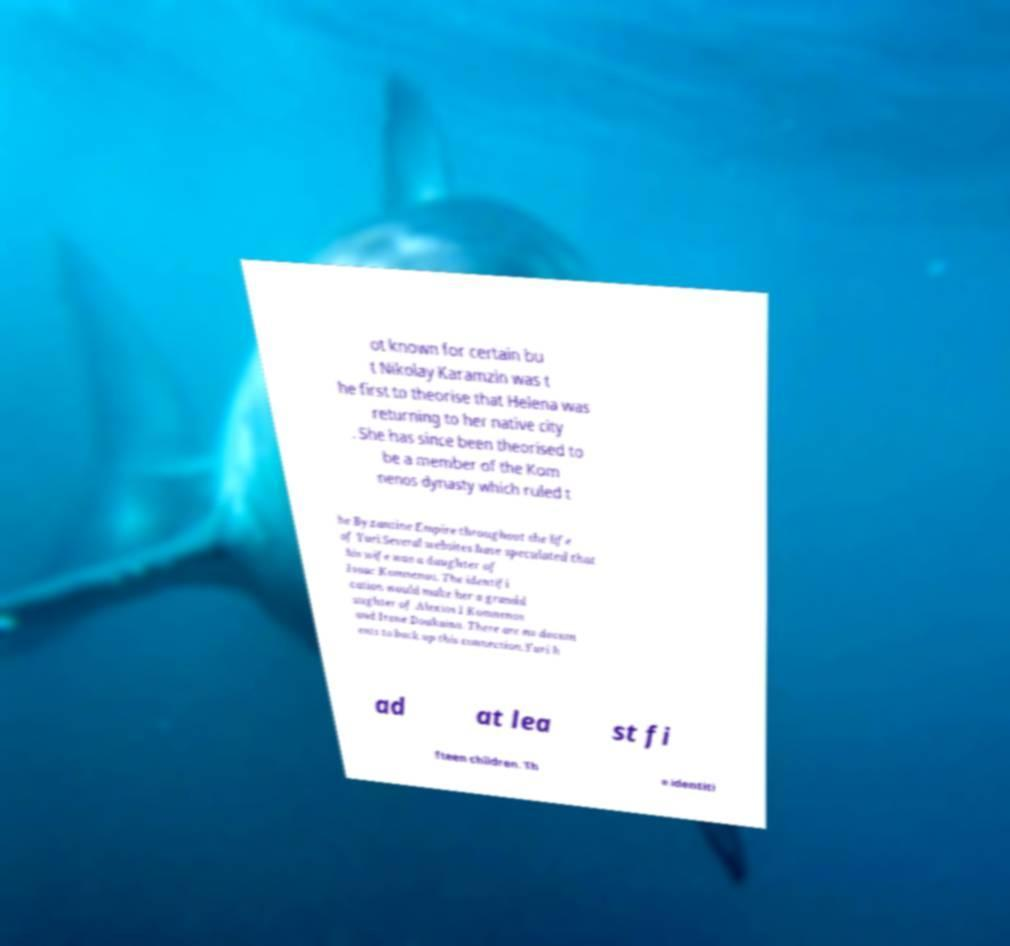Can you accurately transcribe the text from the provided image for me? ot known for certain bu t Nikolay Karamzin was t he first to theorise that Helena was returning to her native city . She has since been theorised to be a member of the Kom nenos dynasty which ruled t he Byzantine Empire throughout the life of Yuri.Several websites have speculated that his wife was a daughter of Isaac Komnenos. The identifi cation would make her a grandd aughter of Alexios I Komnenos and Irene Doukaina. There are no docum ents to back up this connection.Yuri h ad at lea st fi fteen children. Th e identiti 